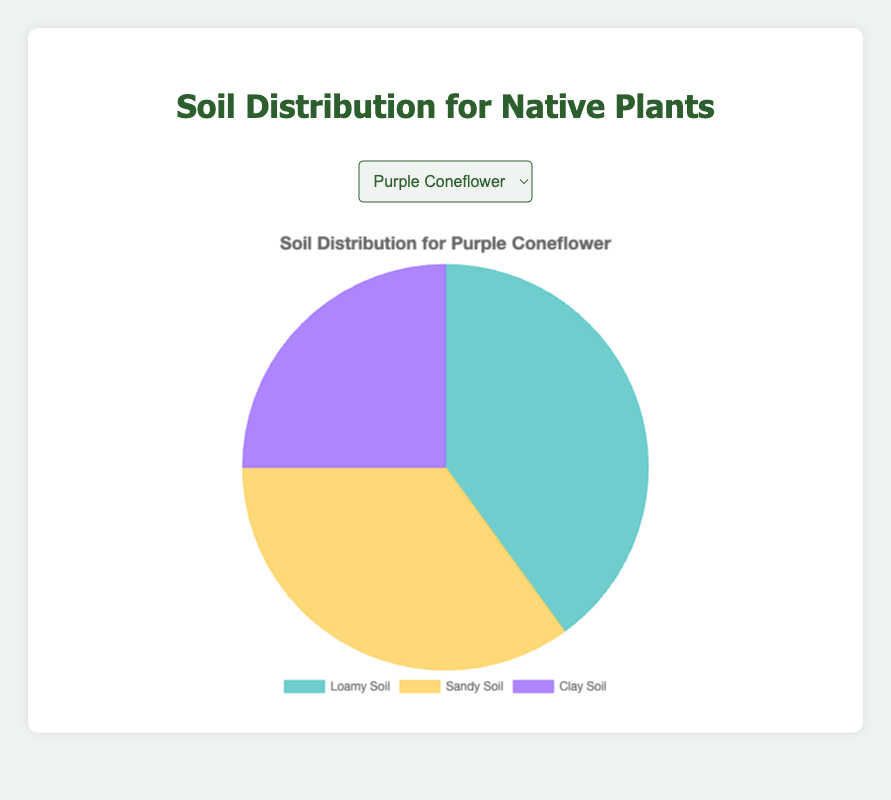What percentage of soil types is best suited for Purple Coneflower? The chart for Purple Coneflower indicates 40% for Loamy Soil, 35% for Sandy Soil, and 25% for Clay Soil. Summing these percentages gives 100%.
Answer: 100% Which soil type is the most frequent for Wild Bergamot? According to the chart, Wild Bergamot has 50% of its occurrence in Loamy Soil, which is higher than Sandy Soil at 30% and Clay Soil at 20%.
Answer: Loamy Soil How does the proportion of Clay Soil for Black-Eyed Susan compare to Purple Coneflower? The proportion of Clay Soil for Black-Eyed Susan is 30%, while for Purple Coneflower, it is 25%. By comparing these two values, we find 30% is greater than 25%.
Answer: Higher What is the average percentage of Sandy Soil across all three plants? Adding the Sandy Soil percentages for Purple Coneflower (35%), Wild Bergamot (30%), and Black-Eyed Susan (25%) gives a total of 90%. Dividing this by the number of plants (3) gives an average of 30%.
Answer: 30% Which plant has the largest proportion of Loamy Soil? The chart indicates that Wild Bergamot has 50% of Loamy Soil, which is higher than Purple Coneflower at 40% and Black-Eyed Susan at 45%.
Answer: Wild Bergamot What is the difference in Loamy Soil percentage between the plant with the highest and the plant with the lowest percentage? Wild Bergamot has 50% Loamy Soil and Purple Coneflower has 40% Loamy Soil. The difference is 50% - 40% = 10%.
Answer: 10% Which soil type is least frequent for Wild Bergamot? According to the chart, Wild Bergamot has 20% Clay Soil, which is lower than Sandy Soil at 30% and Loamy Soil at 50%.
Answer: Clay Soil 